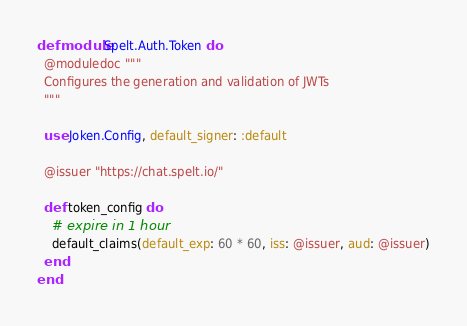Convert code to text. <code><loc_0><loc_0><loc_500><loc_500><_Elixir_>defmodule Spelt.Auth.Token do
  @moduledoc """
  Configures the generation and validation of JWTs
  """

  use Joken.Config, default_signer: :default

  @issuer "https://chat.spelt.io/"

  def token_config do
    # expire in 1 hour
    default_claims(default_exp: 60 * 60, iss: @issuer, aud: @issuer)
  end
end
</code> 